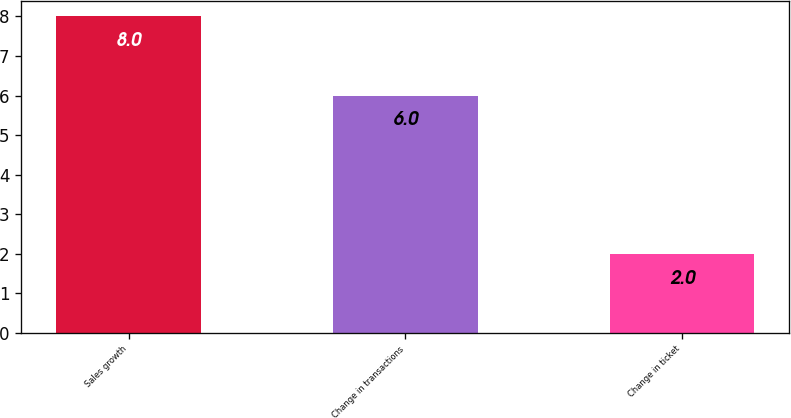Convert chart to OTSL. <chart><loc_0><loc_0><loc_500><loc_500><bar_chart><fcel>Sales growth<fcel>Change in transactions<fcel>Change in ticket<nl><fcel>8<fcel>6<fcel>2<nl></chart> 